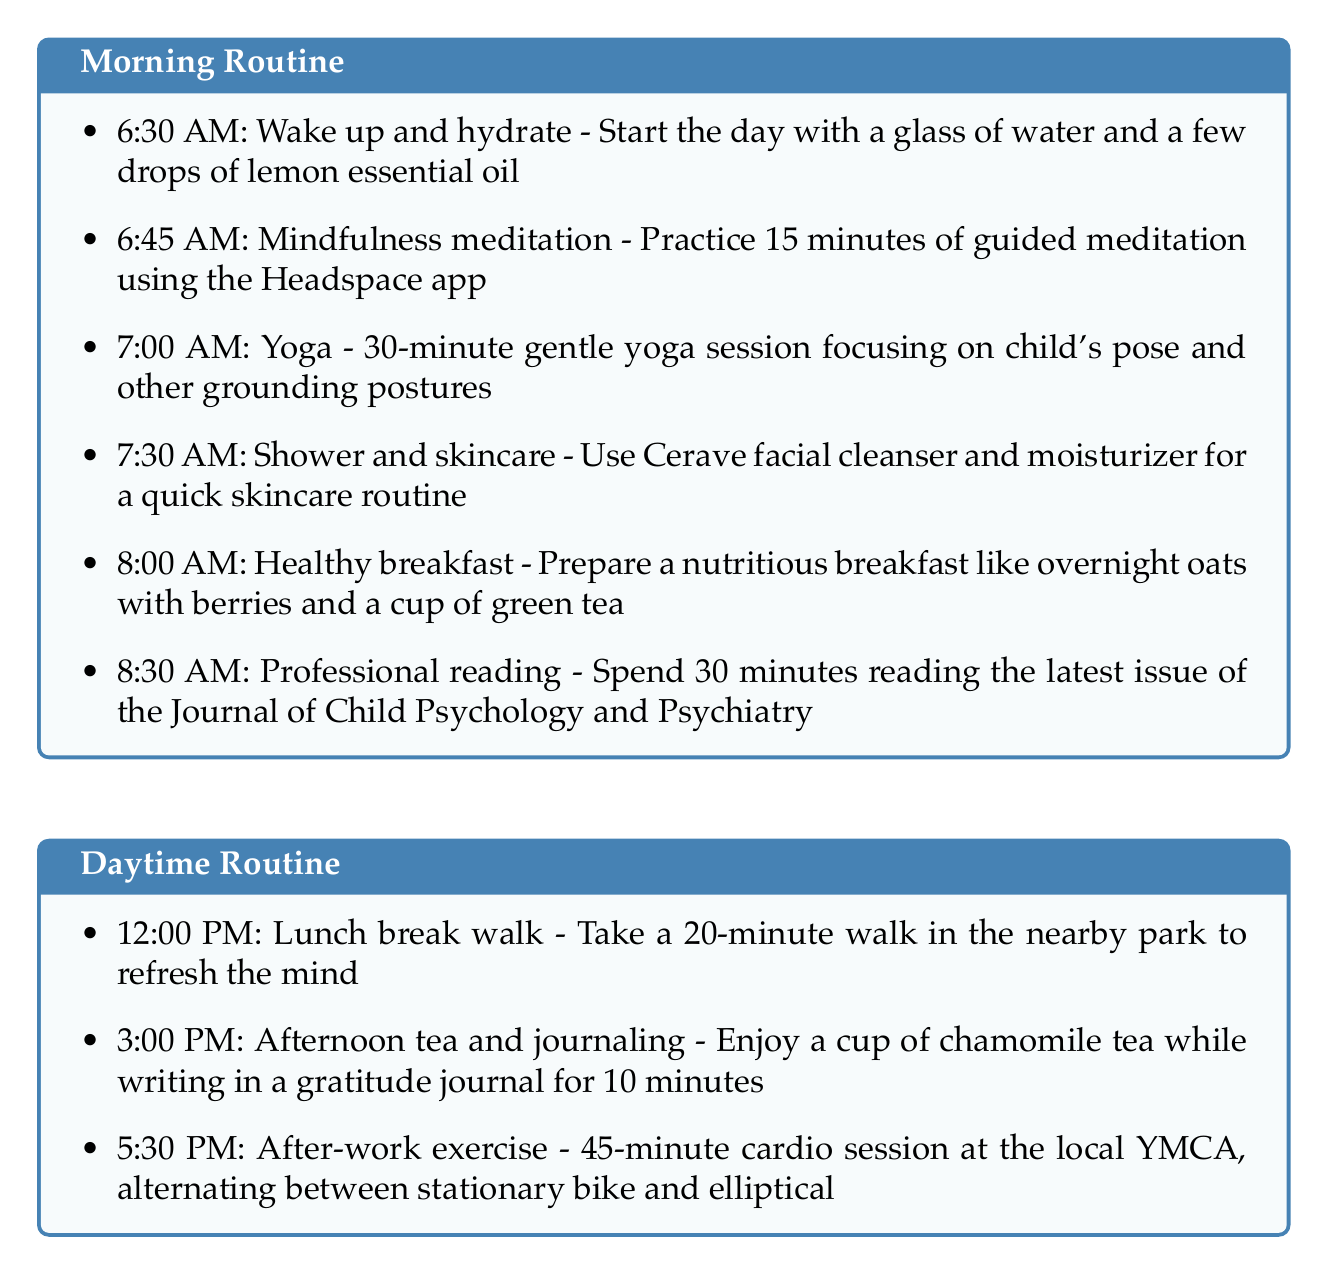What time does the mindfulness meditation start? The specific time for mindfulness meditation is mentioned in the schedule.
Answer: 6:45 AM How long is the yoga session? The duration of the yoga session is provided in the document.
Answer: 30 minutes What activity is scheduled for 3:00 PM? The document lists the activity assigned to 3:00 PM in the daytime routine.
Answer: Afternoon tea and journaling What is the focus of the weekly meal prep? The document describes the focus for the meal prep activity.
Answer: Brain-boosting foods What is the total duration for after-work exercise? The duration of the after-work exercise is mentioned explicitly in the schedule.
Answer: 45 minutes What app is used for evening meditation? The specific app used for evening meditation is noted in the routine.
Answer: Calm app How many hours of sleep are planned? The document states the intended amount of sleep for the night.
Answer: 8 hours What is the first activity of the morning routine? The document specifies the initial activity listed for the morning routine.
Answer: Wake up and hydrate On which day is the book club meeting? The document indicates the day designated for the book club meeting.
Answer: Thursday 